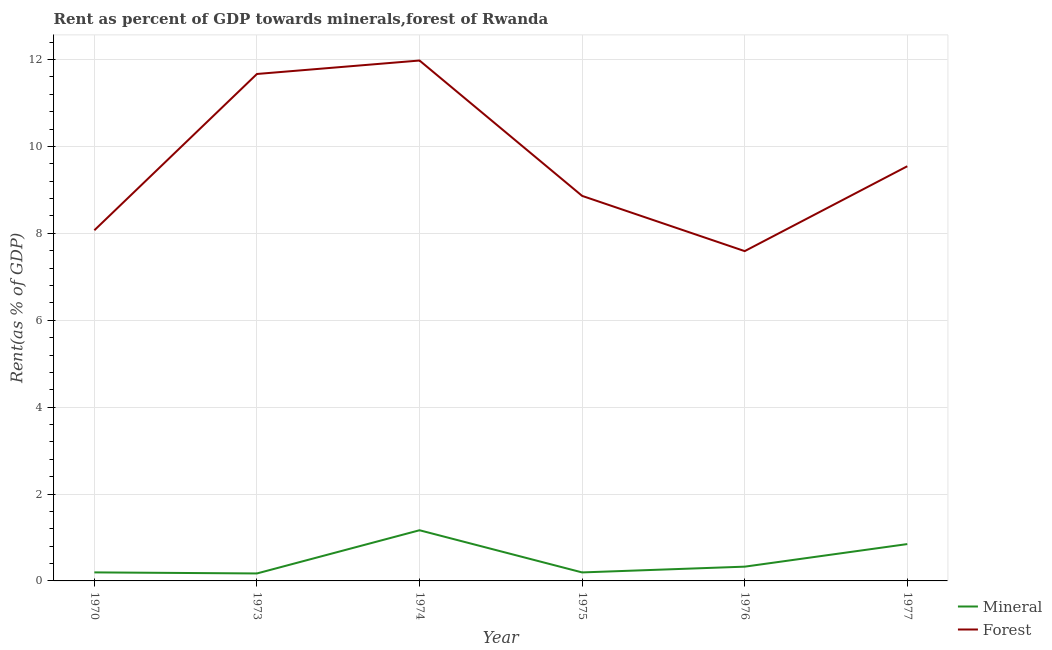How many different coloured lines are there?
Your response must be concise. 2. Is the number of lines equal to the number of legend labels?
Offer a terse response. Yes. What is the forest rent in 1976?
Provide a short and direct response. 7.59. Across all years, what is the maximum mineral rent?
Offer a very short reply. 1.17. Across all years, what is the minimum forest rent?
Your response must be concise. 7.59. In which year was the forest rent maximum?
Your answer should be compact. 1974. In which year was the mineral rent minimum?
Provide a succinct answer. 1973. What is the total forest rent in the graph?
Provide a succinct answer. 57.72. What is the difference between the mineral rent in 1974 and that in 1977?
Keep it short and to the point. 0.32. What is the difference between the forest rent in 1974 and the mineral rent in 1970?
Your answer should be compact. 11.78. What is the average mineral rent per year?
Ensure brevity in your answer.  0.48. In the year 1970, what is the difference between the mineral rent and forest rent?
Provide a short and direct response. -7.87. In how many years, is the mineral rent greater than 10 %?
Keep it short and to the point. 0. What is the ratio of the mineral rent in 1973 to that in 1977?
Offer a very short reply. 0.2. Is the forest rent in 1973 less than that in 1977?
Give a very brief answer. No. Is the difference between the mineral rent in 1970 and 1973 greater than the difference between the forest rent in 1970 and 1973?
Offer a very short reply. Yes. What is the difference between the highest and the second highest forest rent?
Your response must be concise. 0.31. What is the difference between the highest and the lowest mineral rent?
Your answer should be very brief. 0.99. In how many years, is the forest rent greater than the average forest rent taken over all years?
Your answer should be very brief. 2. Does the mineral rent monotonically increase over the years?
Give a very brief answer. No. Is the mineral rent strictly greater than the forest rent over the years?
Provide a succinct answer. No. Is the forest rent strictly less than the mineral rent over the years?
Your answer should be very brief. No. How many years are there in the graph?
Make the answer very short. 6. What is the difference between two consecutive major ticks on the Y-axis?
Your answer should be very brief. 2. Are the values on the major ticks of Y-axis written in scientific E-notation?
Ensure brevity in your answer.  No. Where does the legend appear in the graph?
Provide a succinct answer. Bottom right. What is the title of the graph?
Your answer should be very brief. Rent as percent of GDP towards minerals,forest of Rwanda. Does "Diesel" appear as one of the legend labels in the graph?
Offer a very short reply. No. What is the label or title of the X-axis?
Provide a succinct answer. Year. What is the label or title of the Y-axis?
Ensure brevity in your answer.  Rent(as % of GDP). What is the Rent(as % of GDP) in Mineral in 1970?
Your answer should be very brief. 0.2. What is the Rent(as % of GDP) in Forest in 1970?
Your answer should be very brief. 8.07. What is the Rent(as % of GDP) in Mineral in 1973?
Give a very brief answer. 0.17. What is the Rent(as % of GDP) in Forest in 1973?
Your answer should be very brief. 11.67. What is the Rent(as % of GDP) in Mineral in 1974?
Keep it short and to the point. 1.17. What is the Rent(as % of GDP) of Forest in 1974?
Keep it short and to the point. 11.98. What is the Rent(as % of GDP) in Mineral in 1975?
Ensure brevity in your answer.  0.2. What is the Rent(as % of GDP) of Forest in 1975?
Offer a terse response. 8.86. What is the Rent(as % of GDP) in Mineral in 1976?
Offer a very short reply. 0.33. What is the Rent(as % of GDP) of Forest in 1976?
Your response must be concise. 7.59. What is the Rent(as % of GDP) in Mineral in 1977?
Provide a short and direct response. 0.85. What is the Rent(as % of GDP) of Forest in 1977?
Offer a terse response. 9.54. Across all years, what is the maximum Rent(as % of GDP) of Mineral?
Provide a succinct answer. 1.17. Across all years, what is the maximum Rent(as % of GDP) in Forest?
Offer a terse response. 11.98. Across all years, what is the minimum Rent(as % of GDP) in Mineral?
Your answer should be very brief. 0.17. Across all years, what is the minimum Rent(as % of GDP) of Forest?
Make the answer very short. 7.59. What is the total Rent(as % of GDP) in Mineral in the graph?
Your answer should be very brief. 2.91. What is the total Rent(as % of GDP) of Forest in the graph?
Make the answer very short. 57.72. What is the difference between the Rent(as % of GDP) in Mineral in 1970 and that in 1973?
Provide a succinct answer. 0.02. What is the difference between the Rent(as % of GDP) of Forest in 1970 and that in 1973?
Your answer should be compact. -3.6. What is the difference between the Rent(as % of GDP) in Mineral in 1970 and that in 1974?
Keep it short and to the point. -0.97. What is the difference between the Rent(as % of GDP) in Forest in 1970 and that in 1974?
Make the answer very short. -3.91. What is the difference between the Rent(as % of GDP) in Mineral in 1970 and that in 1975?
Ensure brevity in your answer.  0. What is the difference between the Rent(as % of GDP) in Forest in 1970 and that in 1975?
Your response must be concise. -0.79. What is the difference between the Rent(as % of GDP) in Mineral in 1970 and that in 1976?
Your answer should be very brief. -0.13. What is the difference between the Rent(as % of GDP) of Forest in 1970 and that in 1976?
Provide a short and direct response. 0.48. What is the difference between the Rent(as % of GDP) in Mineral in 1970 and that in 1977?
Your answer should be compact. -0.65. What is the difference between the Rent(as % of GDP) of Forest in 1970 and that in 1977?
Offer a very short reply. -1.47. What is the difference between the Rent(as % of GDP) of Mineral in 1973 and that in 1974?
Offer a terse response. -0.99. What is the difference between the Rent(as % of GDP) of Forest in 1973 and that in 1974?
Offer a very short reply. -0.31. What is the difference between the Rent(as % of GDP) in Mineral in 1973 and that in 1975?
Provide a short and direct response. -0.02. What is the difference between the Rent(as % of GDP) in Forest in 1973 and that in 1975?
Offer a terse response. 2.81. What is the difference between the Rent(as % of GDP) in Mineral in 1973 and that in 1976?
Make the answer very short. -0.16. What is the difference between the Rent(as % of GDP) in Forest in 1973 and that in 1976?
Provide a short and direct response. 4.08. What is the difference between the Rent(as % of GDP) of Mineral in 1973 and that in 1977?
Provide a short and direct response. -0.68. What is the difference between the Rent(as % of GDP) in Forest in 1973 and that in 1977?
Offer a terse response. 2.12. What is the difference between the Rent(as % of GDP) in Mineral in 1974 and that in 1975?
Provide a succinct answer. 0.97. What is the difference between the Rent(as % of GDP) in Forest in 1974 and that in 1975?
Provide a short and direct response. 3.12. What is the difference between the Rent(as % of GDP) of Mineral in 1974 and that in 1976?
Offer a terse response. 0.84. What is the difference between the Rent(as % of GDP) in Forest in 1974 and that in 1976?
Your answer should be very brief. 4.39. What is the difference between the Rent(as % of GDP) in Mineral in 1974 and that in 1977?
Provide a short and direct response. 0.32. What is the difference between the Rent(as % of GDP) of Forest in 1974 and that in 1977?
Your answer should be very brief. 2.43. What is the difference between the Rent(as % of GDP) in Mineral in 1975 and that in 1976?
Provide a short and direct response. -0.13. What is the difference between the Rent(as % of GDP) of Forest in 1975 and that in 1976?
Your answer should be compact. 1.27. What is the difference between the Rent(as % of GDP) in Mineral in 1975 and that in 1977?
Your answer should be very brief. -0.65. What is the difference between the Rent(as % of GDP) in Forest in 1975 and that in 1977?
Provide a succinct answer. -0.68. What is the difference between the Rent(as % of GDP) of Mineral in 1976 and that in 1977?
Your answer should be very brief. -0.52. What is the difference between the Rent(as % of GDP) of Forest in 1976 and that in 1977?
Ensure brevity in your answer.  -1.95. What is the difference between the Rent(as % of GDP) of Mineral in 1970 and the Rent(as % of GDP) of Forest in 1973?
Give a very brief answer. -11.47. What is the difference between the Rent(as % of GDP) in Mineral in 1970 and the Rent(as % of GDP) in Forest in 1974?
Your answer should be compact. -11.78. What is the difference between the Rent(as % of GDP) in Mineral in 1970 and the Rent(as % of GDP) in Forest in 1975?
Offer a very short reply. -8.67. What is the difference between the Rent(as % of GDP) of Mineral in 1970 and the Rent(as % of GDP) of Forest in 1976?
Your response must be concise. -7.39. What is the difference between the Rent(as % of GDP) in Mineral in 1970 and the Rent(as % of GDP) in Forest in 1977?
Make the answer very short. -9.35. What is the difference between the Rent(as % of GDP) of Mineral in 1973 and the Rent(as % of GDP) of Forest in 1974?
Your answer should be very brief. -11.81. What is the difference between the Rent(as % of GDP) of Mineral in 1973 and the Rent(as % of GDP) of Forest in 1975?
Provide a succinct answer. -8.69. What is the difference between the Rent(as % of GDP) in Mineral in 1973 and the Rent(as % of GDP) in Forest in 1976?
Your response must be concise. -7.42. What is the difference between the Rent(as % of GDP) in Mineral in 1973 and the Rent(as % of GDP) in Forest in 1977?
Provide a short and direct response. -9.37. What is the difference between the Rent(as % of GDP) of Mineral in 1974 and the Rent(as % of GDP) of Forest in 1975?
Offer a very short reply. -7.7. What is the difference between the Rent(as % of GDP) of Mineral in 1974 and the Rent(as % of GDP) of Forest in 1976?
Provide a succinct answer. -6.42. What is the difference between the Rent(as % of GDP) in Mineral in 1974 and the Rent(as % of GDP) in Forest in 1977?
Your answer should be compact. -8.38. What is the difference between the Rent(as % of GDP) of Mineral in 1975 and the Rent(as % of GDP) of Forest in 1976?
Provide a succinct answer. -7.4. What is the difference between the Rent(as % of GDP) of Mineral in 1975 and the Rent(as % of GDP) of Forest in 1977?
Offer a very short reply. -9.35. What is the difference between the Rent(as % of GDP) of Mineral in 1976 and the Rent(as % of GDP) of Forest in 1977?
Make the answer very short. -9.22. What is the average Rent(as % of GDP) of Mineral per year?
Ensure brevity in your answer.  0.48. What is the average Rent(as % of GDP) of Forest per year?
Your response must be concise. 9.62. In the year 1970, what is the difference between the Rent(as % of GDP) of Mineral and Rent(as % of GDP) of Forest?
Ensure brevity in your answer.  -7.87. In the year 1973, what is the difference between the Rent(as % of GDP) in Mineral and Rent(as % of GDP) in Forest?
Offer a terse response. -11.5. In the year 1974, what is the difference between the Rent(as % of GDP) in Mineral and Rent(as % of GDP) in Forest?
Your answer should be compact. -10.81. In the year 1975, what is the difference between the Rent(as % of GDP) in Mineral and Rent(as % of GDP) in Forest?
Offer a very short reply. -8.67. In the year 1976, what is the difference between the Rent(as % of GDP) in Mineral and Rent(as % of GDP) in Forest?
Keep it short and to the point. -7.26. In the year 1977, what is the difference between the Rent(as % of GDP) of Mineral and Rent(as % of GDP) of Forest?
Keep it short and to the point. -8.7. What is the ratio of the Rent(as % of GDP) in Mineral in 1970 to that in 1973?
Offer a very short reply. 1.14. What is the ratio of the Rent(as % of GDP) in Forest in 1970 to that in 1973?
Offer a terse response. 0.69. What is the ratio of the Rent(as % of GDP) in Mineral in 1970 to that in 1974?
Offer a terse response. 0.17. What is the ratio of the Rent(as % of GDP) in Forest in 1970 to that in 1974?
Give a very brief answer. 0.67. What is the ratio of the Rent(as % of GDP) of Forest in 1970 to that in 1975?
Provide a short and direct response. 0.91. What is the ratio of the Rent(as % of GDP) of Mineral in 1970 to that in 1976?
Make the answer very short. 0.6. What is the ratio of the Rent(as % of GDP) of Forest in 1970 to that in 1976?
Your answer should be compact. 1.06. What is the ratio of the Rent(as % of GDP) of Mineral in 1970 to that in 1977?
Ensure brevity in your answer.  0.23. What is the ratio of the Rent(as % of GDP) in Forest in 1970 to that in 1977?
Your answer should be very brief. 0.85. What is the ratio of the Rent(as % of GDP) in Mineral in 1973 to that in 1974?
Keep it short and to the point. 0.15. What is the ratio of the Rent(as % of GDP) in Forest in 1973 to that in 1974?
Give a very brief answer. 0.97. What is the ratio of the Rent(as % of GDP) of Mineral in 1973 to that in 1975?
Your response must be concise. 0.88. What is the ratio of the Rent(as % of GDP) in Forest in 1973 to that in 1975?
Ensure brevity in your answer.  1.32. What is the ratio of the Rent(as % of GDP) of Mineral in 1973 to that in 1976?
Keep it short and to the point. 0.52. What is the ratio of the Rent(as % of GDP) in Forest in 1973 to that in 1976?
Offer a terse response. 1.54. What is the ratio of the Rent(as % of GDP) of Mineral in 1973 to that in 1977?
Your answer should be very brief. 0.2. What is the ratio of the Rent(as % of GDP) of Forest in 1973 to that in 1977?
Keep it short and to the point. 1.22. What is the ratio of the Rent(as % of GDP) in Mineral in 1974 to that in 1975?
Your answer should be compact. 5.96. What is the ratio of the Rent(as % of GDP) in Forest in 1974 to that in 1975?
Make the answer very short. 1.35. What is the ratio of the Rent(as % of GDP) of Mineral in 1974 to that in 1976?
Give a very brief answer. 3.55. What is the ratio of the Rent(as % of GDP) of Forest in 1974 to that in 1976?
Give a very brief answer. 1.58. What is the ratio of the Rent(as % of GDP) of Mineral in 1974 to that in 1977?
Your answer should be very brief. 1.38. What is the ratio of the Rent(as % of GDP) in Forest in 1974 to that in 1977?
Your answer should be very brief. 1.25. What is the ratio of the Rent(as % of GDP) of Mineral in 1975 to that in 1976?
Ensure brevity in your answer.  0.6. What is the ratio of the Rent(as % of GDP) in Forest in 1975 to that in 1976?
Offer a terse response. 1.17. What is the ratio of the Rent(as % of GDP) of Mineral in 1975 to that in 1977?
Your response must be concise. 0.23. What is the ratio of the Rent(as % of GDP) in Forest in 1975 to that in 1977?
Provide a short and direct response. 0.93. What is the ratio of the Rent(as % of GDP) of Mineral in 1976 to that in 1977?
Your answer should be very brief. 0.39. What is the ratio of the Rent(as % of GDP) of Forest in 1976 to that in 1977?
Provide a short and direct response. 0.8. What is the difference between the highest and the second highest Rent(as % of GDP) in Mineral?
Your response must be concise. 0.32. What is the difference between the highest and the second highest Rent(as % of GDP) in Forest?
Your answer should be very brief. 0.31. What is the difference between the highest and the lowest Rent(as % of GDP) in Mineral?
Keep it short and to the point. 0.99. What is the difference between the highest and the lowest Rent(as % of GDP) in Forest?
Your response must be concise. 4.39. 